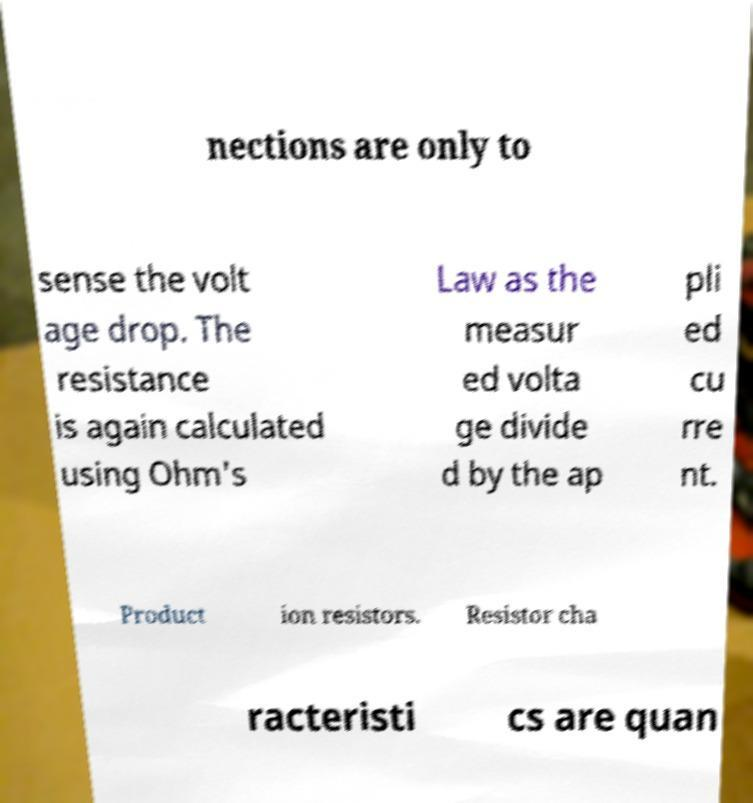Can you accurately transcribe the text from the provided image for me? nections are only to sense the volt age drop. The resistance is again calculated using Ohm's Law as the measur ed volta ge divide d by the ap pli ed cu rre nt. Product ion resistors. Resistor cha racteristi cs are quan 